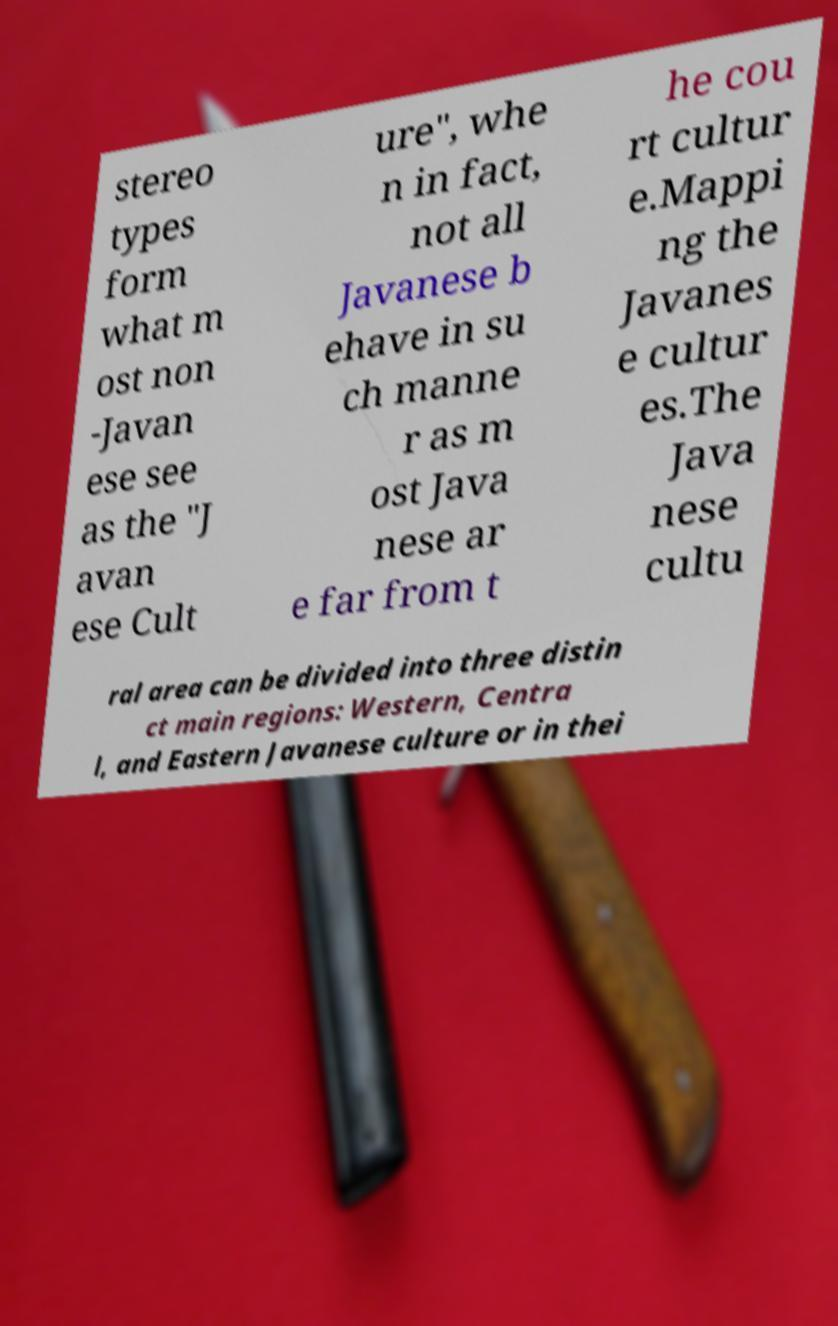Can you accurately transcribe the text from the provided image for me? stereo types form what m ost non -Javan ese see as the "J avan ese Cult ure", whe n in fact, not all Javanese b ehave in su ch manne r as m ost Java nese ar e far from t he cou rt cultur e.Mappi ng the Javanes e cultur es.The Java nese cultu ral area can be divided into three distin ct main regions: Western, Centra l, and Eastern Javanese culture or in thei 